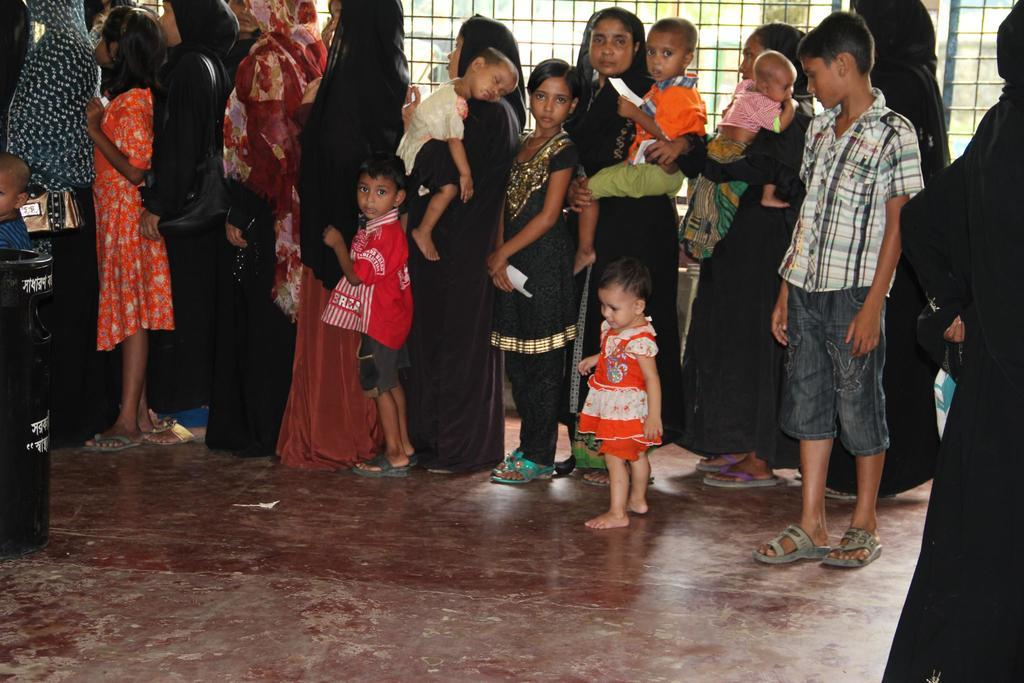What are the people in the image doing? The people in the image are standing in a line. What can be seen in the background of the image? There is iron fencing in the image. What type of sugar is being sold at the ticket counter in the image? There is no ticket counter or sugar present in the image; it only shows people standing in a line and iron fencing in the background. 